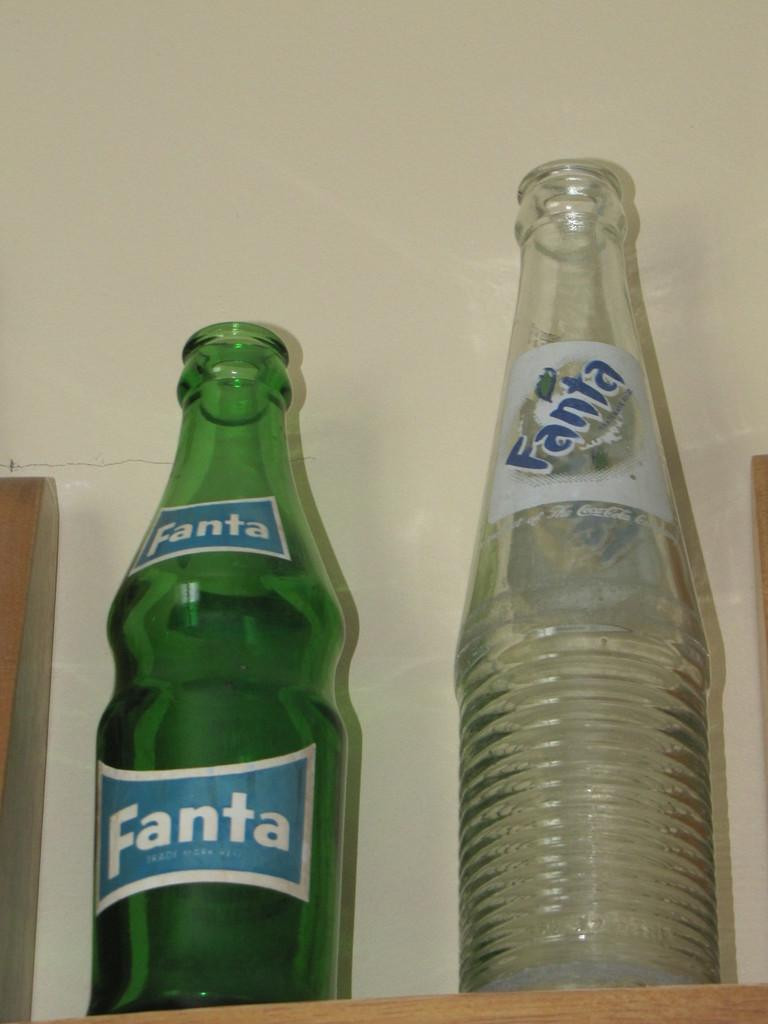<image>
Relay a brief, clear account of the picture shown. Two Fanta bottles are next to each other. 